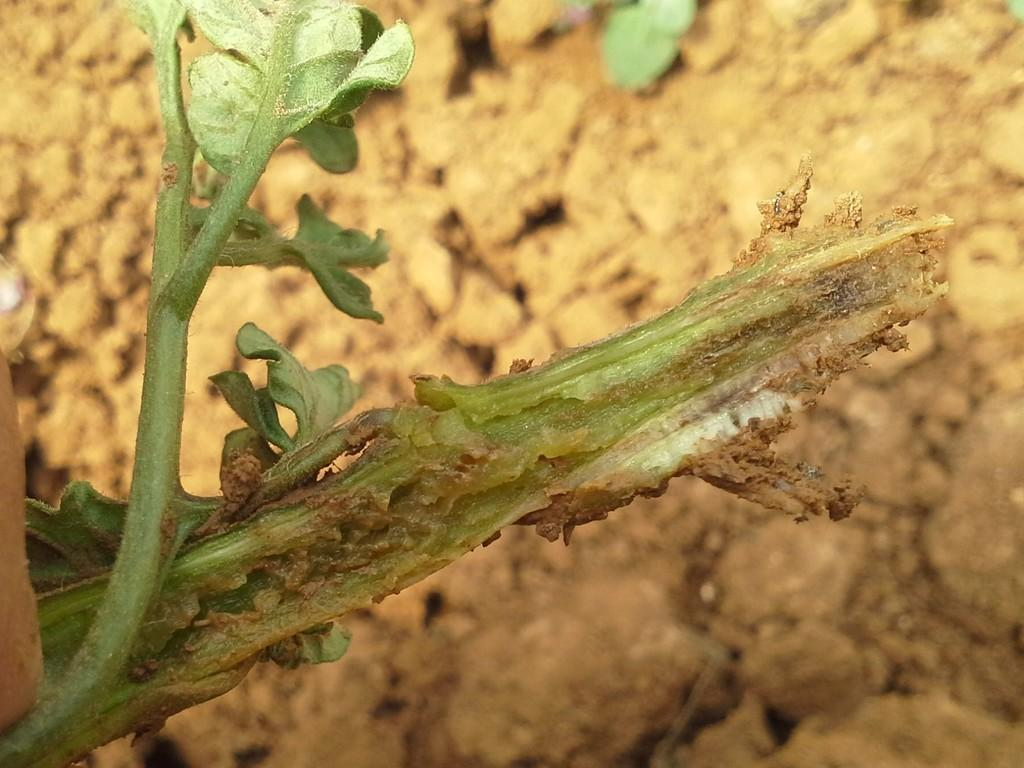What is the main subject of the image? There is a plant in the image. Can you describe the background of the image? The background of the image is blurred. Who is the creator of the peace symbol in the image? There is no peace symbol present in the image, and therefore no creator can be identified. 